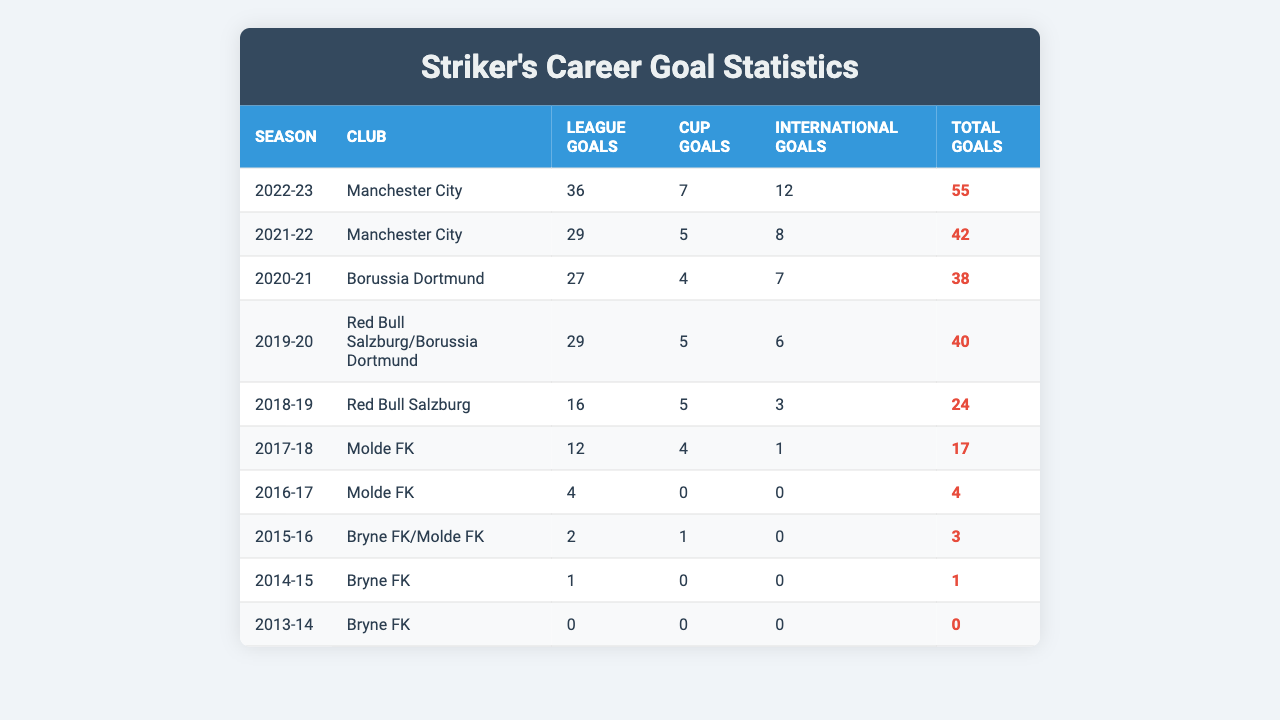What was the striker's total goal count for the 2022-23 season? In the 2022-23 season, under Manchester City, the total goals scored was 55, as indicated in the Total Goals column.
Answer: 55 How many league goals did the striker score in the 2021-22 season? The striker scored 29 league goals in the 2021-22 season, which can be found in the League Goals column for that season.
Answer: 29 Which season did the striker have the least total goals, and what was that number? The least total goals were scored in the 2013-14 season, where the striker scored 0 total goals as shown in the Total Goals column for that season.
Answer: 2013-14 season, 0 goals How many total goals did the striker score in all seasons combined? By summing the Total Goals across all seasons (55 + 42 + 38 + 40 + 24 + 17 + 4 + 3 + 1 + 0), the total is 224.
Answer: 224 What is the average number of cup goals scored by the striker over the 10 seasons? Adding up all cup goals (7 + 5 + 4 + 5 + 5 + 4 + 0 + 1 + 0 + 0) gives 31 goals; dividing by 10 seasons results in an average of 3.1 cup goals per season.
Answer: 3.1 Did the striker ever score more international goals than league goals in a single season? In the 2022-23 season, the striker scored 12 international goals, which is greater than the 36 league goals he scored that season.
Answer: No What season showed the most significant increase in total goals compared to the previous season? To find this, we look for the largest difference between total goals of consecutive seasons: between 2020-21 (38) and 2021-22 (42), there's an increase of 4 goals. However, the biggest jump is from 2017-18 (17) to 2018-19 (24), a rise of 7 goals.
Answer: 2018-19 season, with an increase of 7 goals In which season did the striker score the maximum number of cup goals? The maximum cup goals scored were in the 2022-23 season with 7 cup goals, which is the highest in the Cup Goals column of the table.
Answer: 2022-23 season Calculate the total number of league goals scored by the striker from 2016-17 to 2021-22. The league goals for those seasons are 4 (2016-17) + 12 (2017-18) + 29 (2018-19) + 27 (2020-21) + 29 (2021-22) = 101. Thus, total league goals from 2016-17 to 2021-22 is 101.
Answer: 101 What was the highest total goals scored in any single season? The highest total goals scored in a single season was 55 in the 2022-23 season, indicated in the Total Goals column.
Answer: 55 